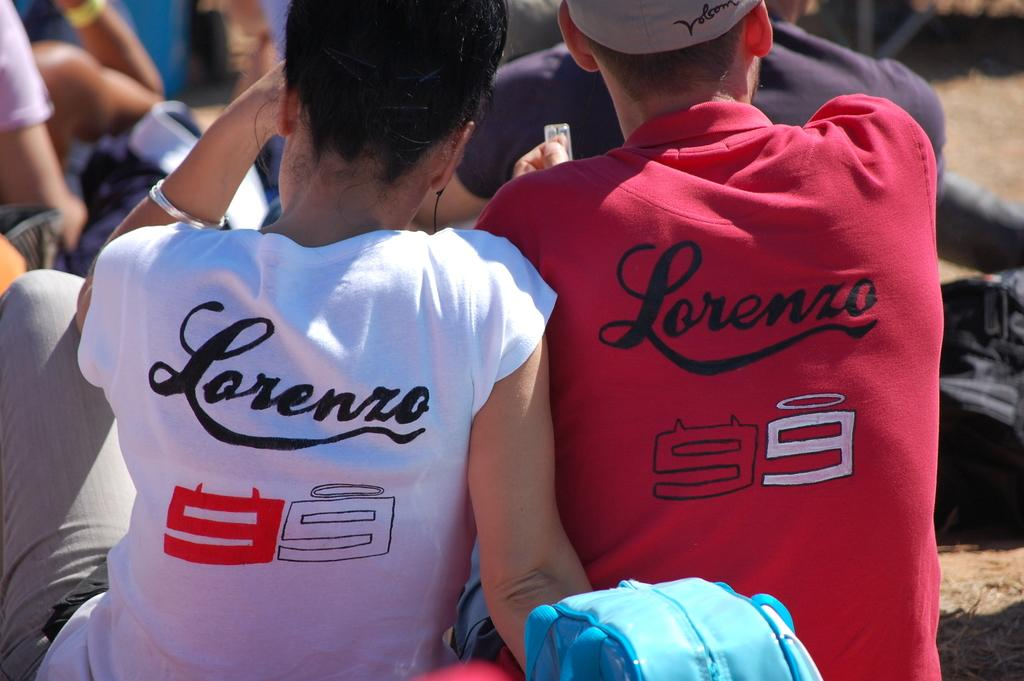<image>
Render a clear and concise summary of the photo. A young couple wearing a white and a red tshirt that says Lorenzo 99 